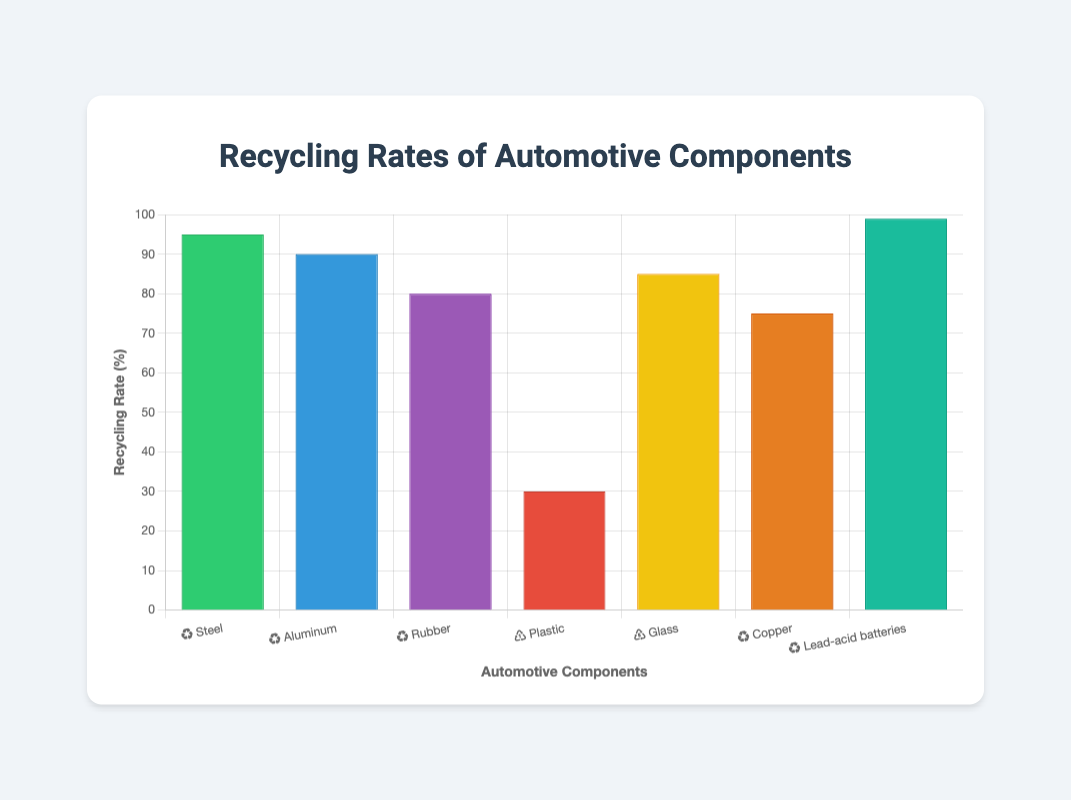What's the recycling rate of Lead-acid batteries? The figure shows the recycling rate for various automotive components, and Lead-acid batteries have a recycling rate bar reaching up to 99%.
Answer: 99% Which material has the lowest recycling rate? According to the chart, the lowest recycling rate is indicated by the shortest bar, which corresponds to Plastic at 30%.
Answer: Plastic Compare the recycling rates of Steel and Copper. Which one is higher and by how much? Steel has a recycling rate of 95%, whereas Copper's rate is 75%. Subtracting Copper's rate from Steel's gives 95% - 75% = 20%.
Answer: Steel by 20% What's the average recycling rate of Steel, Aluminum, and Glass? Add the recycling rates of Steel (95%), Aluminum (90%), and Glass (85%) and then divide by 3. (95% + 90% + 85%) / 3 = 270% / 3 = 90%.
Answer: 90% How many material types have a recycling rate of 80% or higher? The materials with recycling rates of 80% or higher are Steel (95%), Aluminum (90%), Rubber (80%), Glass (85%), Copper (75%) is less than 80%, and Lead-acid batteries (99%). Counting these, there are 5 such materials.
Answer: 5 What is the difference in recycling rates between Rubber and Plastic? Rubber has a recycling rate of 80%, and Plastic has 30%. Subtracting these gives 80% - 30% = 50%.
Answer: 50% Which material has the second highest recycling rate and what is it? The second highest recycling rate appears after Lead-acid batteries (99%), which is Steel with a recycling rate of 95%.
Answer: Steel at 95% If Rubber's recycling rate increased by 15%, what would the new rate be? Rubber's current recycling rate is 80%. Adding 15% to this gives 80% + 15% = 95%.
Answer: 95% What is the total recycling rate for Aluminum and Plastic combined? Summing the recycling rates of Aluminum (90%) and Plastic (30%) gives 90% + 30% = 120%.
Answer: 120% If the target minimum recycling rate is 85%, which materials currently do not meet this target? Materials with recycling rates less than 85% are identified as Plastic (30%), Copper (75%), and Rubber (80%). These do not meet the target.
Answer: Plastic, Copper, Rubber 